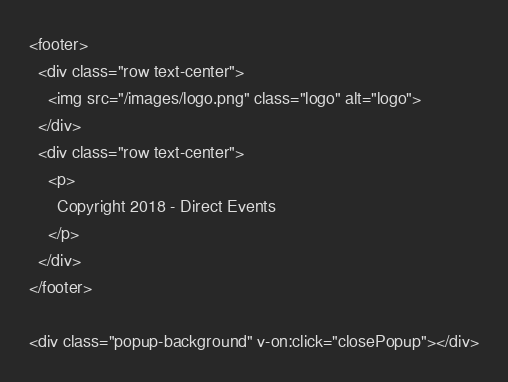Convert code to text. <code><loc_0><loc_0><loc_500><loc_500><_PHP_><footer>
  <div class="row text-center">
    <img src="/images/logo.png" class="logo" alt="logo">
  </div>
  <div class="row text-center">
    <p>
      Copyright 2018 - Direct Events
    </p>
  </div>
</footer>

<div class="popup-background" v-on:click="closePopup"></div>
</code> 